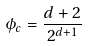<formula> <loc_0><loc_0><loc_500><loc_500>\phi _ { c } = \frac { d + 2 } { 2 ^ { d + 1 } }</formula> 